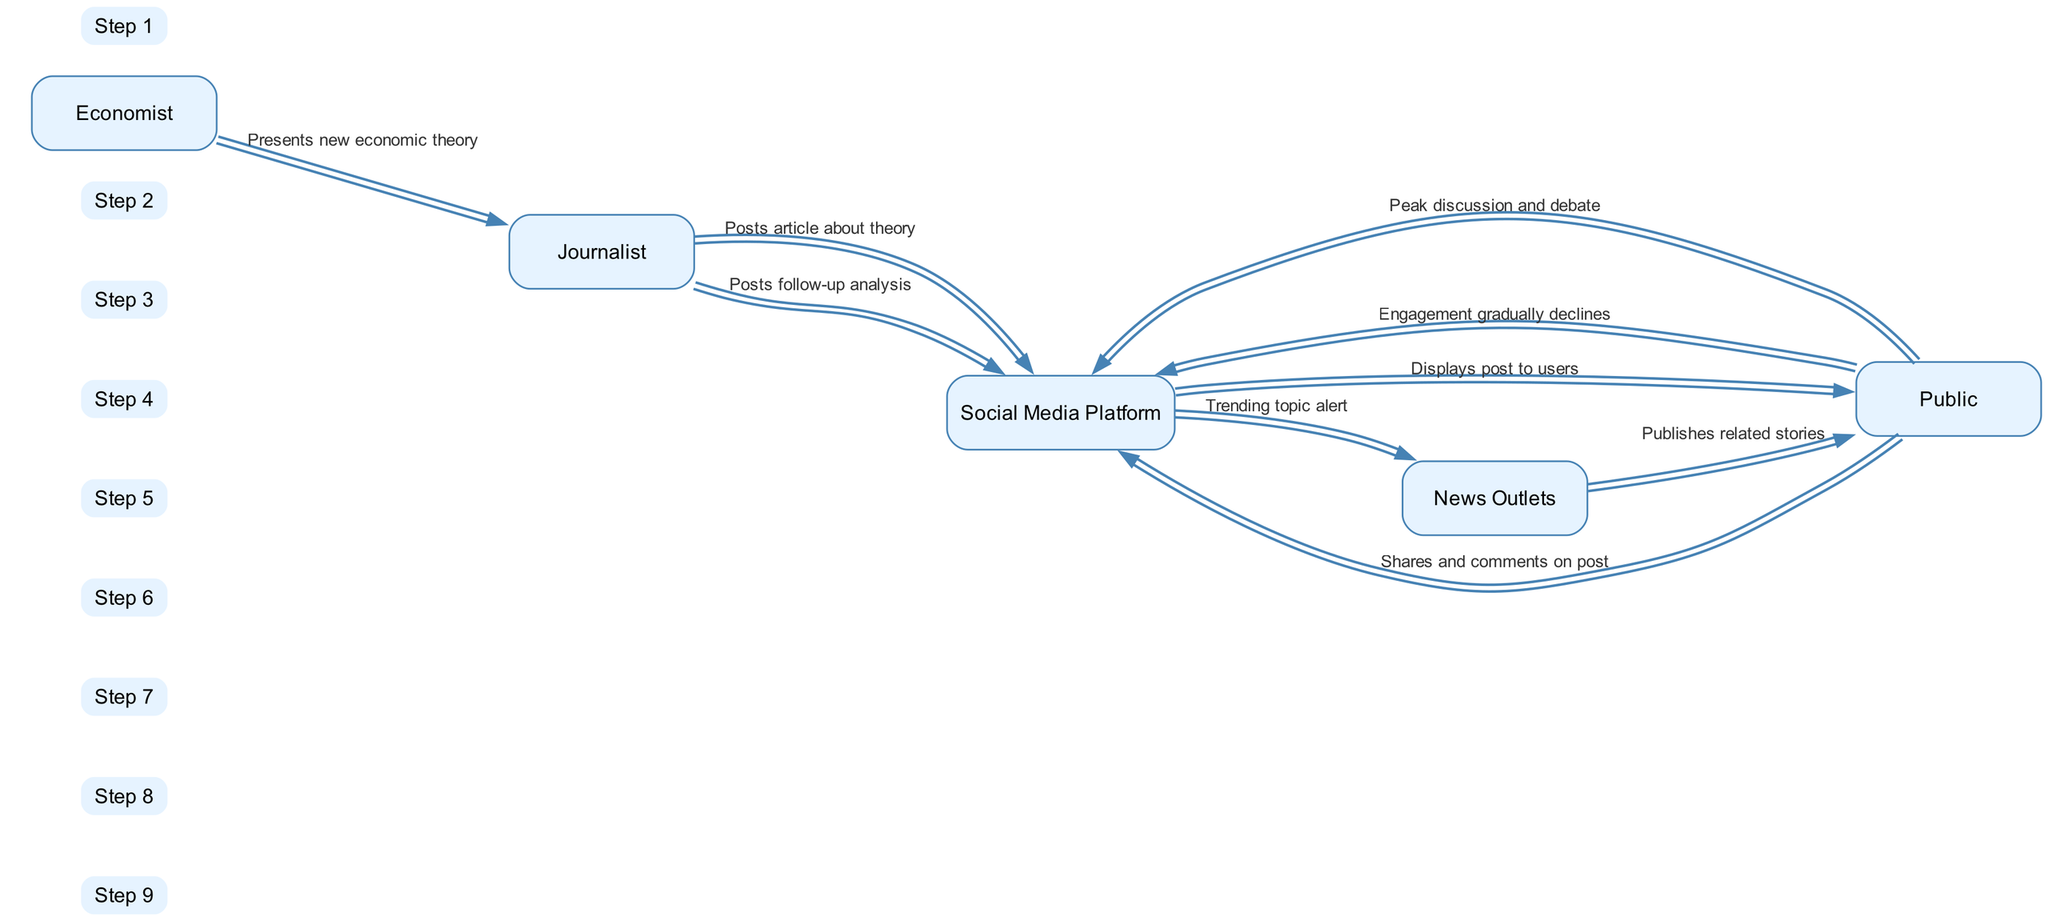What is the first interaction in the sequence? The first interaction is between the Economist and the Journalist, where the Economist presents a new economic theory to the Journalist.
Answer: Presents new economic theory Which actor receives the trending topic alert? The Social Media Platform sends a trending topic alert to the News Outlets. This can be determined by following the sequence from the Public's engagement to the alert directed at News Outlets.
Answer: News Outlets How many steps are there in the engagement lifecycle? There are a total of eight steps in the engagement lifecycle as outlined in the sequence. They can be counted from the initial message to the last interaction.
Answer: Eight What does the Public do after the Social Media Platform displays the post? After the Social Media Platform displays the post, the Public shares and comments on the post. This follows directly from the sequential actions in the diagram.
Answer: Shares and comments on post What happens after the peak discussion and debate by the Public? The engagement gradually declines after the peak discussion and debate, indicating a decrease in interactions on the Social Media Platform. This is the final action listed in the sequence.
Answer: Engagement gradually declines Which actor posts a follow-up analysis? The Journalist posts a follow-up analysis after the peak discussion and debate by the Public has occurred. This sequence position indicates the Journalist's continued involvement.
Answer: Journalist Who publishes related stories following trending topic alert? The News Outlets publish related stories after receiving the trending topic alert from the Social Media Platform. This shows the role of News Outlets in the lifecycle.
Answer: Publishes related stories What is the last message sent in the sequence? The last message in the sequence indicates that the Public's engagement is gradually declining, marking the ending interaction of the cycle.
Answer: Engagement gradually declines 